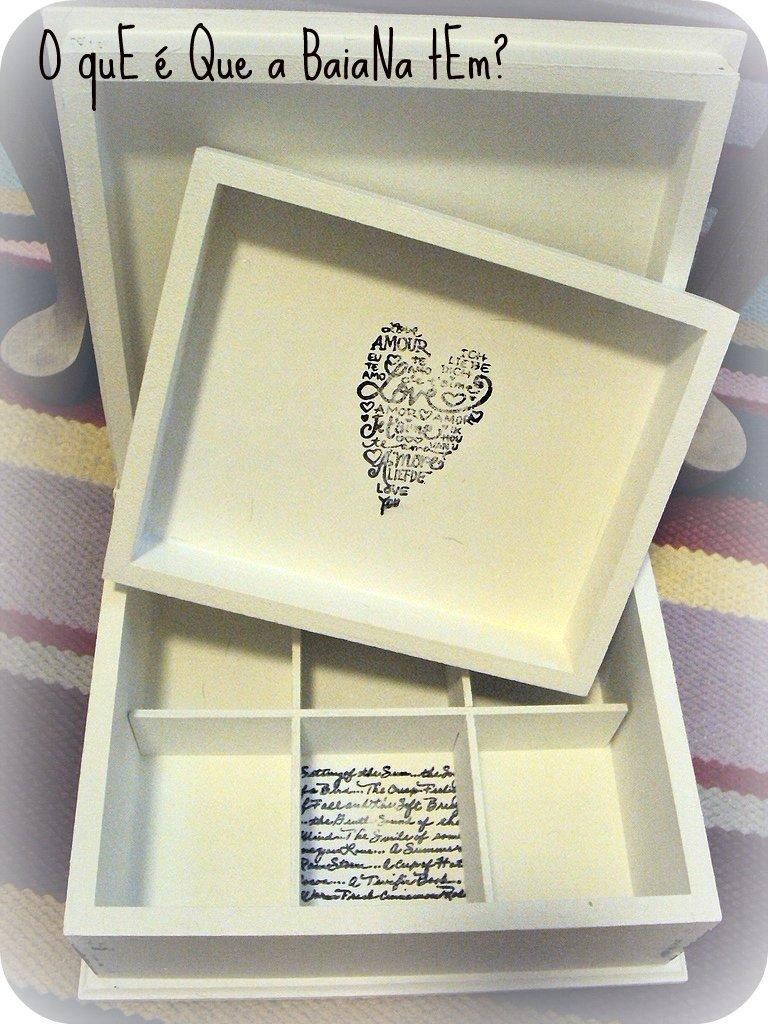<image>
Summarize the visual content of the image. A white jewellery box has a heart created by words on the inside, one of which is love. 